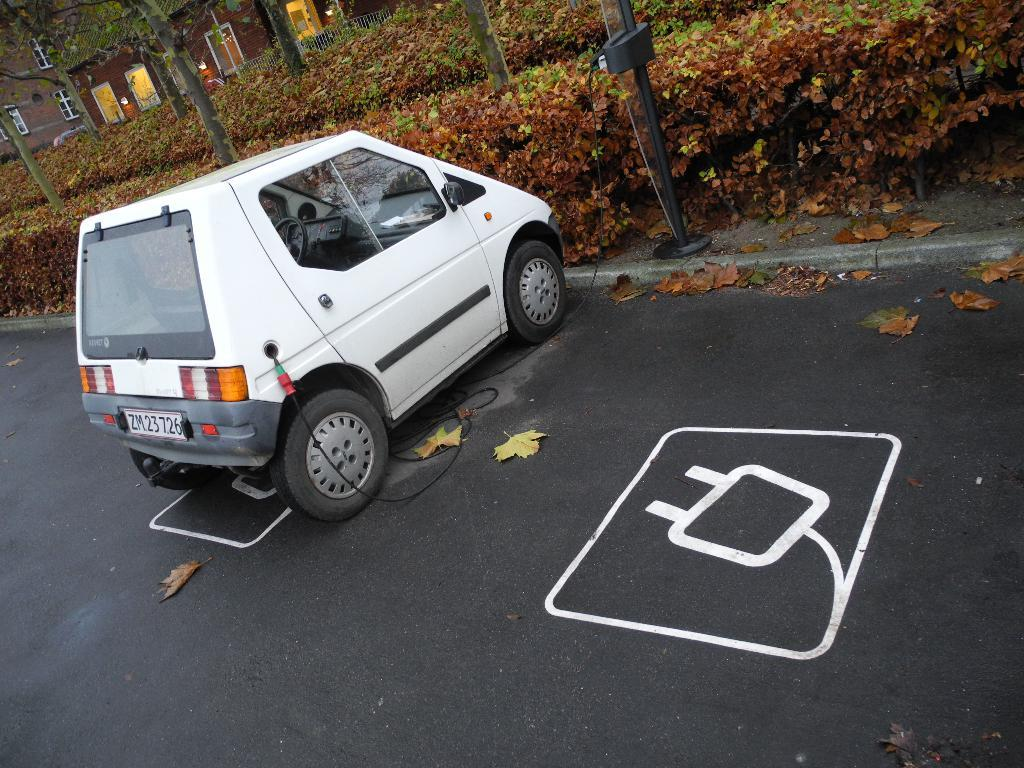What is on the road in the image? There is a vehicle on the road in the image. What can be observed about the appearance of the vehicle? The vehicle has painted images on it. What is located beside the road? There is a pole beside the road. What type of vegetation is visible behind the road? There are plants and trees behind the road. Where is the house in the image? The house is in the left top part of the image. How does the wall twist in the image? There is no wall present in the image, so it cannot be determined how a wall might twist. 